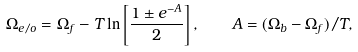Convert formula to latex. <formula><loc_0><loc_0><loc_500><loc_500>\Omega _ { e / o } = \Omega _ { f } - T \ln \left [ \frac { 1 \pm e ^ { - A } } { 2 } \right ] , \quad A = ( \Omega _ { b } - \Omega _ { f } ) / T ,</formula> 